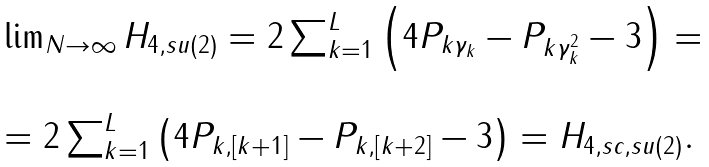<formula> <loc_0><loc_0><loc_500><loc_500>\begin{array} { l } \lim _ { N \rightarrow \infty } H _ { 4 , s u ( 2 ) } = 2 \sum _ { k = 1 } ^ { L } \left ( 4 P _ { k \gamma _ { k } } - P _ { k \gamma _ { k } ^ { 2 } } - 3 \right ) = \\ \\ = 2 \sum _ { k = 1 } ^ { L } \left ( 4 P _ { k , \left [ k + 1 \right ] } - P _ { k , \left [ k + 2 \right ] } - 3 \right ) = H _ { 4 , s c , s u ( 2 ) } . \end{array}</formula> 